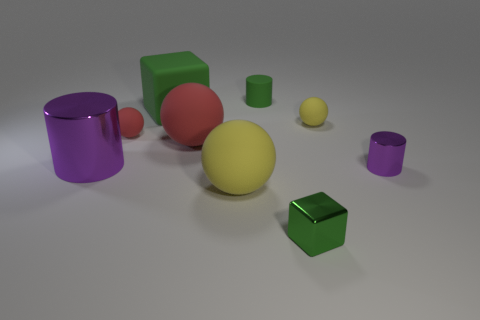What number of other things are the same size as the green shiny thing?
Make the answer very short. 4. Does the large purple thing have the same shape as the tiny purple object?
Make the answer very short. Yes. Are there any small blue cylinders made of the same material as the small red sphere?
Ensure brevity in your answer.  No. What color is the small thing that is both in front of the big purple thing and to the right of the tiny green metal cube?
Provide a short and direct response. Purple. There is a cylinder that is left of the large yellow matte object; what material is it?
Your response must be concise. Metal. Are there any tiny yellow rubber objects of the same shape as the tiny purple object?
Offer a terse response. No. What number of other things are there of the same shape as the tiny red object?
Your answer should be very brief. 3. There is a large yellow rubber thing; is its shape the same as the metal object that is on the left side of the big green block?
Your answer should be very brief. No. Are there any other things that are the same material as the tiny red ball?
Offer a very short reply. Yes. What is the material of the large green object that is the same shape as the tiny green metallic thing?
Provide a short and direct response. Rubber. 